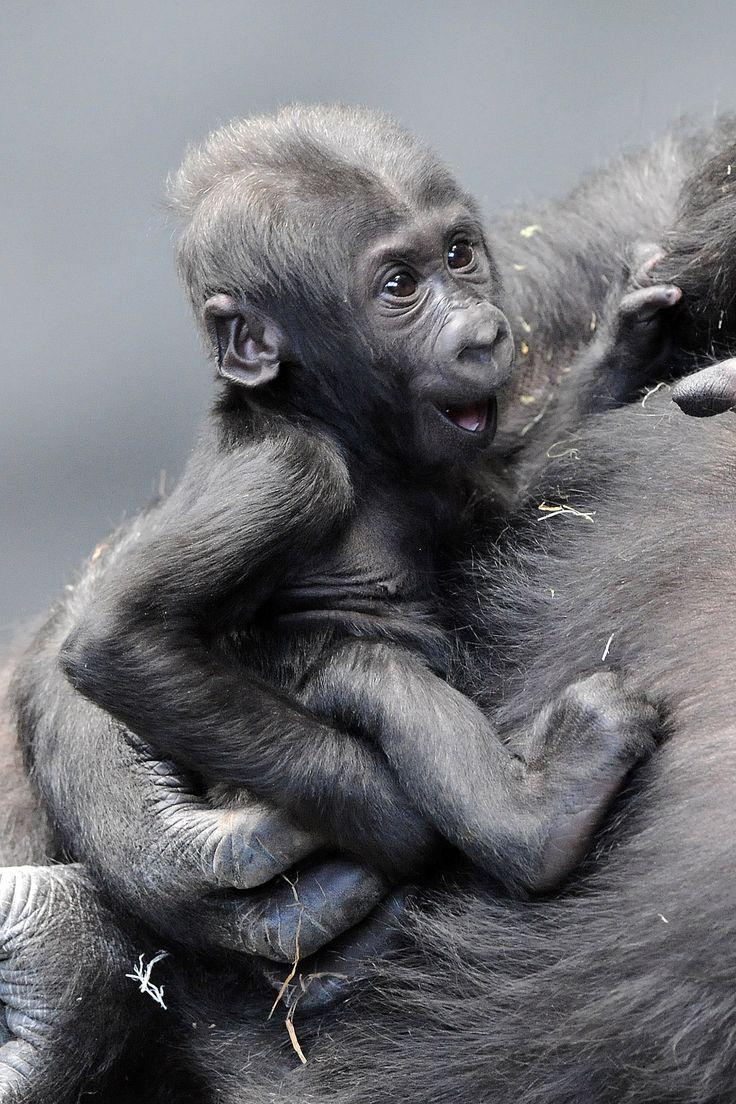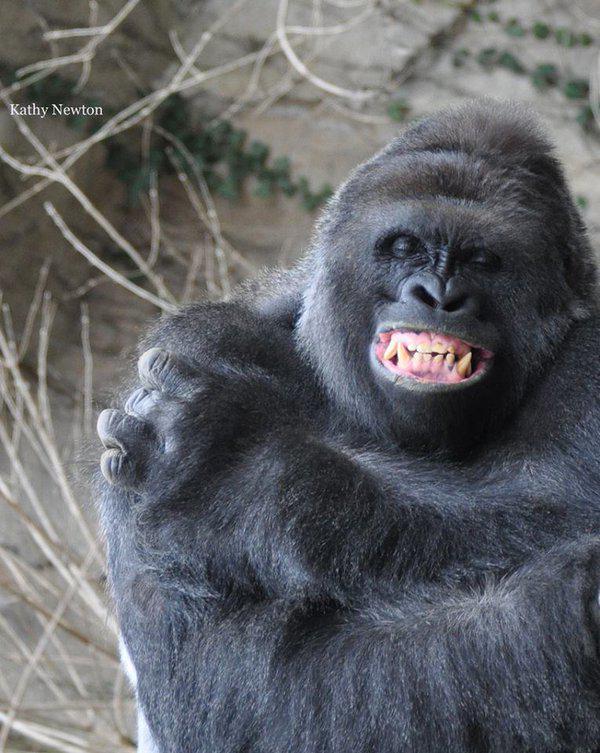The first image is the image on the left, the second image is the image on the right. Considering the images on both sides, is "The left image shows a large forward-facing ape with its elbows bent and the hand on the right side flipping up its middle finger." valid? Answer yes or no. No. The first image is the image on the left, the second image is the image on the right. Evaluate the accuracy of this statement regarding the images: "An animal is looking at the camera and flashing its middle finger in the left image.". Is it true? Answer yes or no. No. 